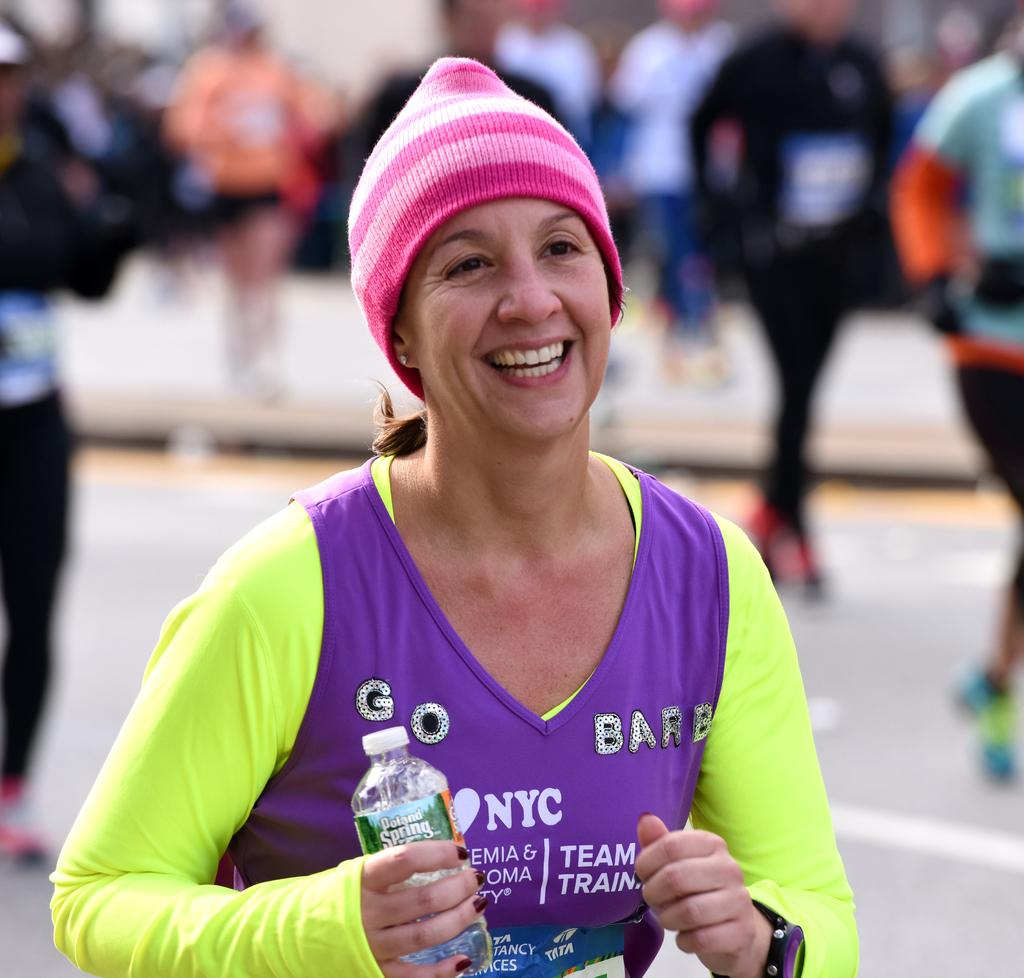Who is present in the image? There is a woman in the image. What is the woman doing in the image? The woman is smiling and holding a bottle. Can you describe the bottle in the image? The bottle has a wire cap. What can be seen in the background of the image? The background of the image is blurry, and there are people visible. What type of apparatus is being used for breakfast in the image? There is no apparatus or reference to breakfast present in the image. 